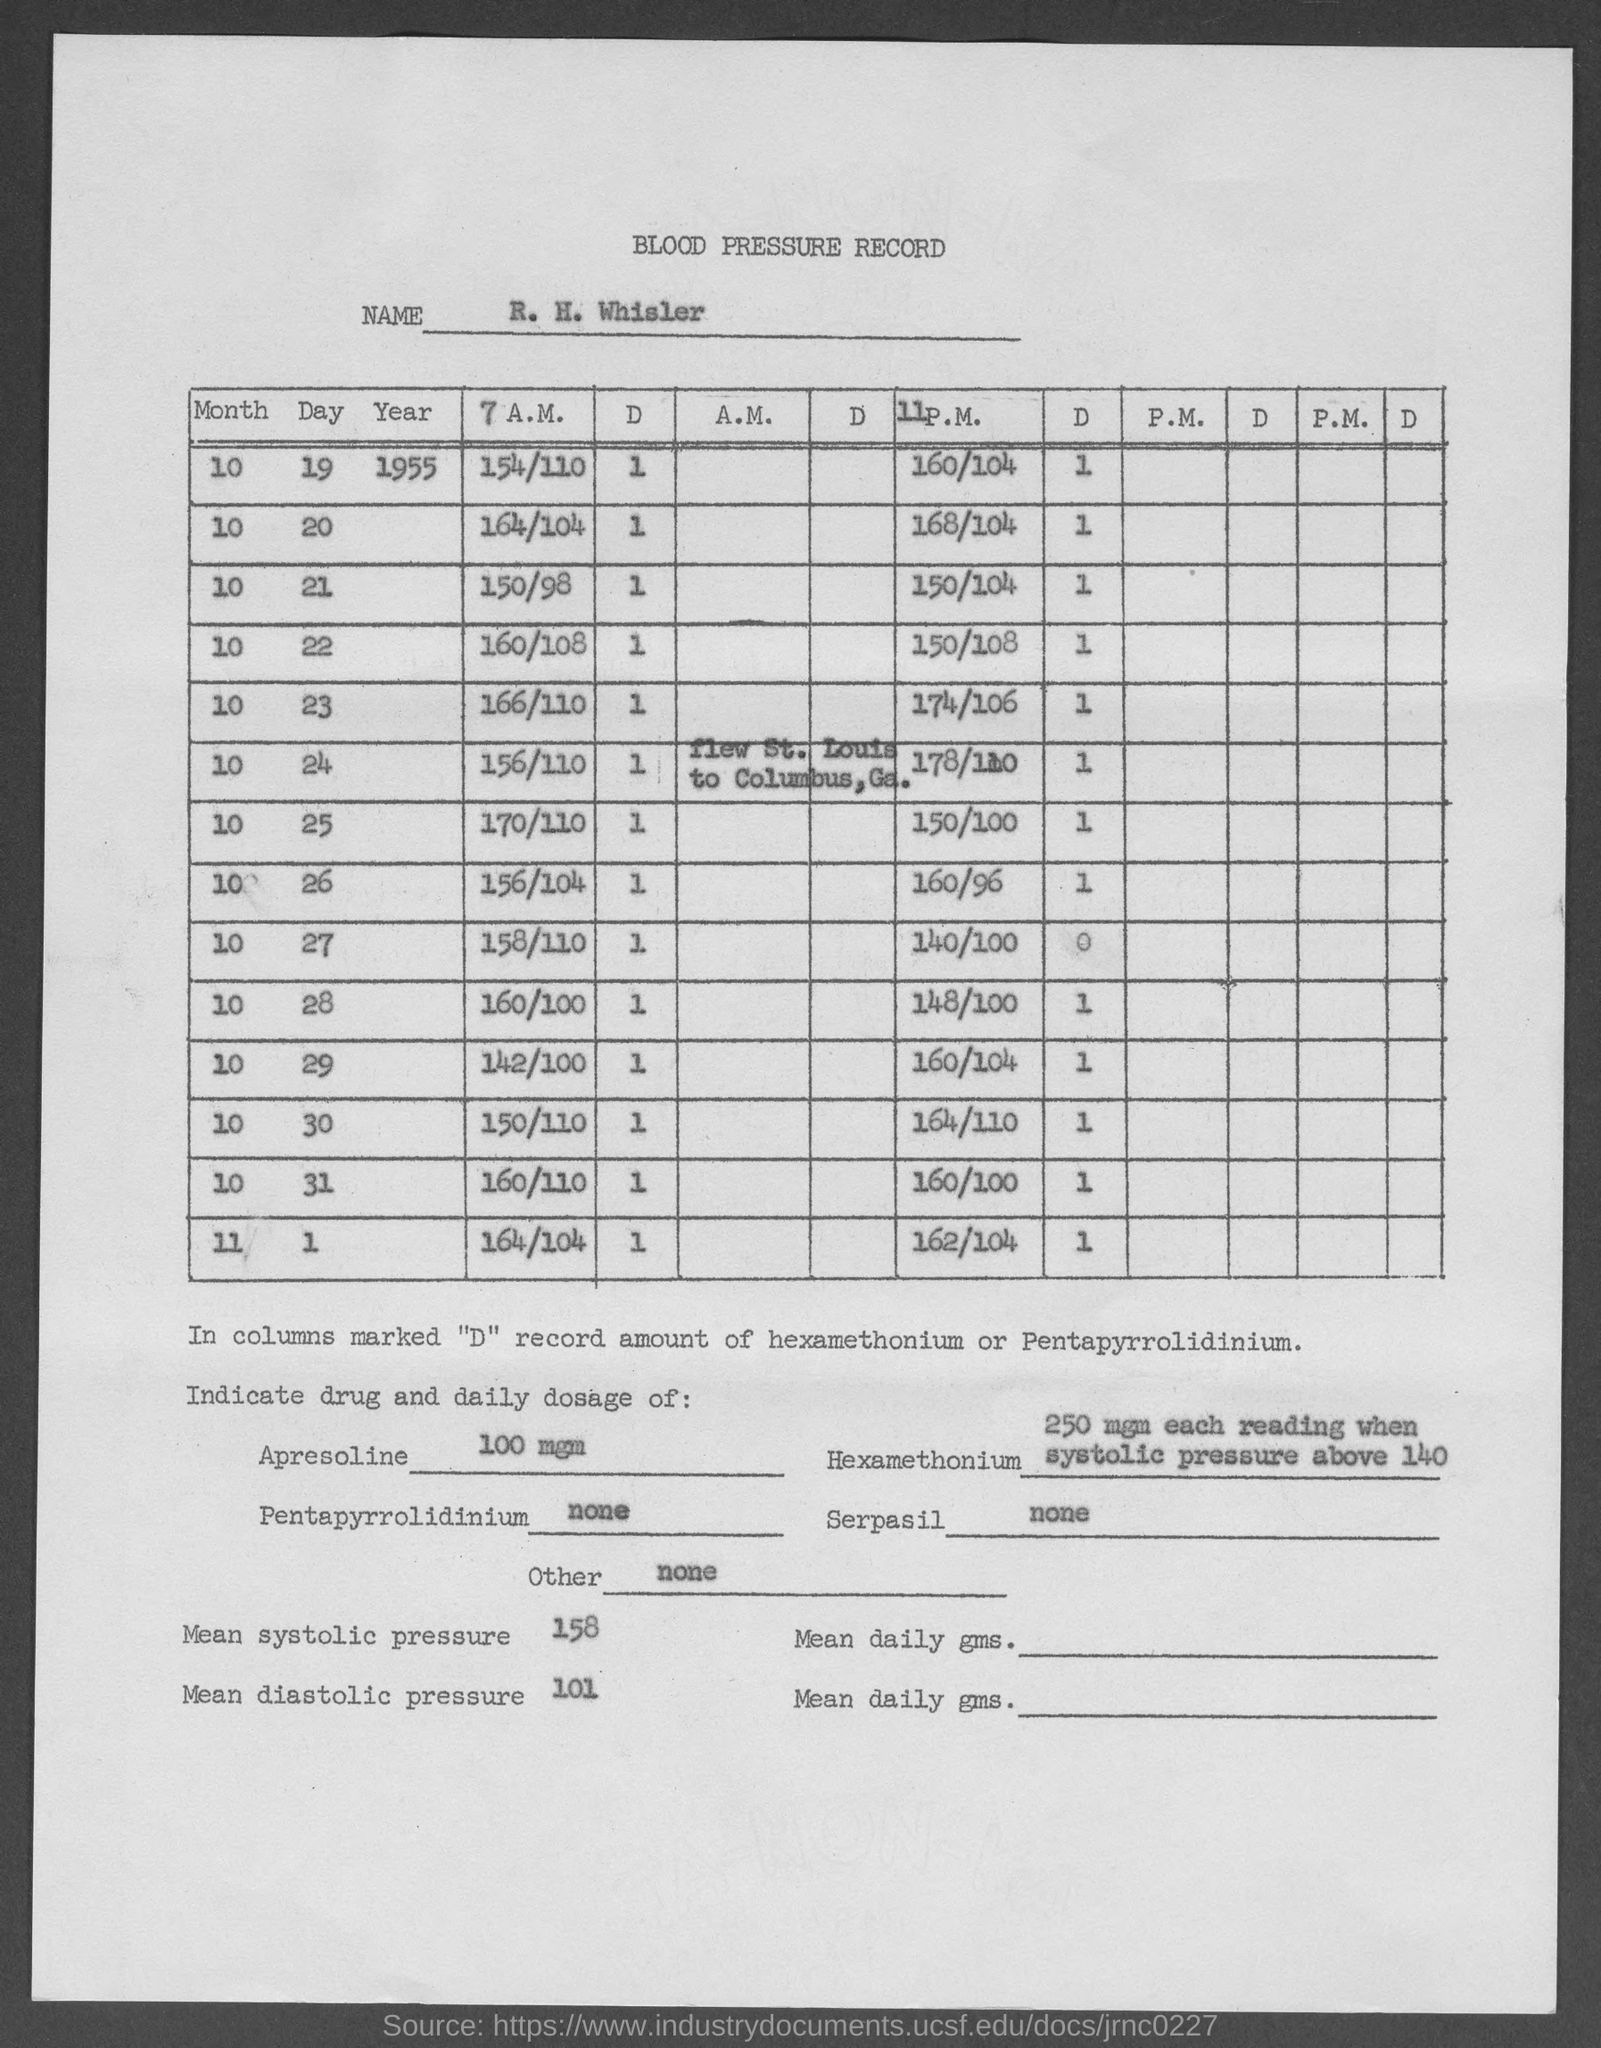Give some essential details in this illustration. The daily dosage of Serpasil has not been specified. Systolic pressure is the pressure in the arteries when the heart beats and contracts. A systolic pressure of 158 would indicate that the pressure in the arteries is 158 mmHg. The diastolic pressure is the pressure in the arteries when the heart rests between beats. In this case, the diastolic pressure is 101. The recommended daily dose of Apresoline is 100 mg. Pentapyrrolidinium does not have a daily dosage. 